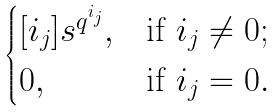<formula> <loc_0><loc_0><loc_500><loc_500>\begin{cases} [ i _ { j } ] s ^ { q ^ { i _ { j } } } , & \text {if $i_{j}\ne 0$} ; \\ 0 , & \text {if $i_{j}=0$} . \end{cases}</formula> 